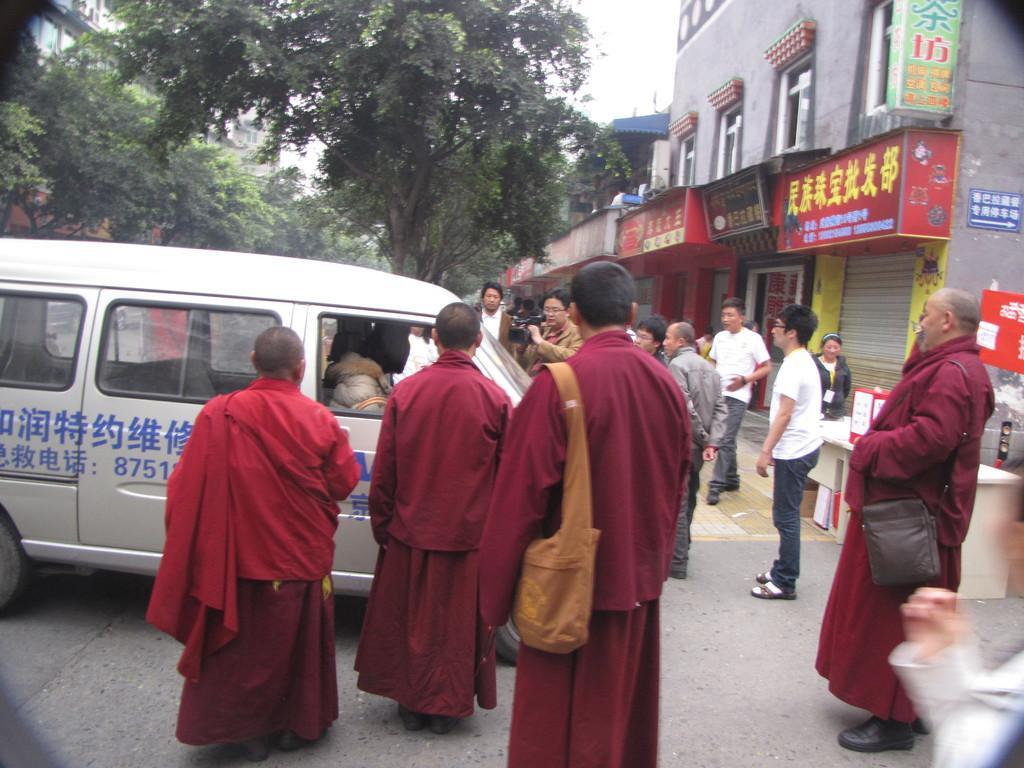Describe this image in one or two sentences. In the picture there are four priests standing there is a vehicle in front of them,the behind the vehicle there are few people standing one person is taking a video of the van,to the right side there are some stores and a building above it, in the background there are some trees and sky. 